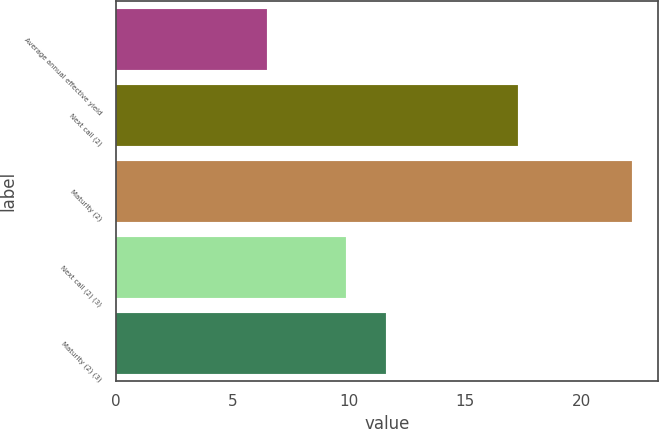Convert chart. <chart><loc_0><loc_0><loc_500><loc_500><bar_chart><fcel>Average annual effective yield<fcel>Next call (2)<fcel>Maturity (2)<fcel>Next call (2) (3)<fcel>Maturity (2) (3)<nl><fcel>6.49<fcel>17.3<fcel>22.2<fcel>9.9<fcel>11.6<nl></chart> 